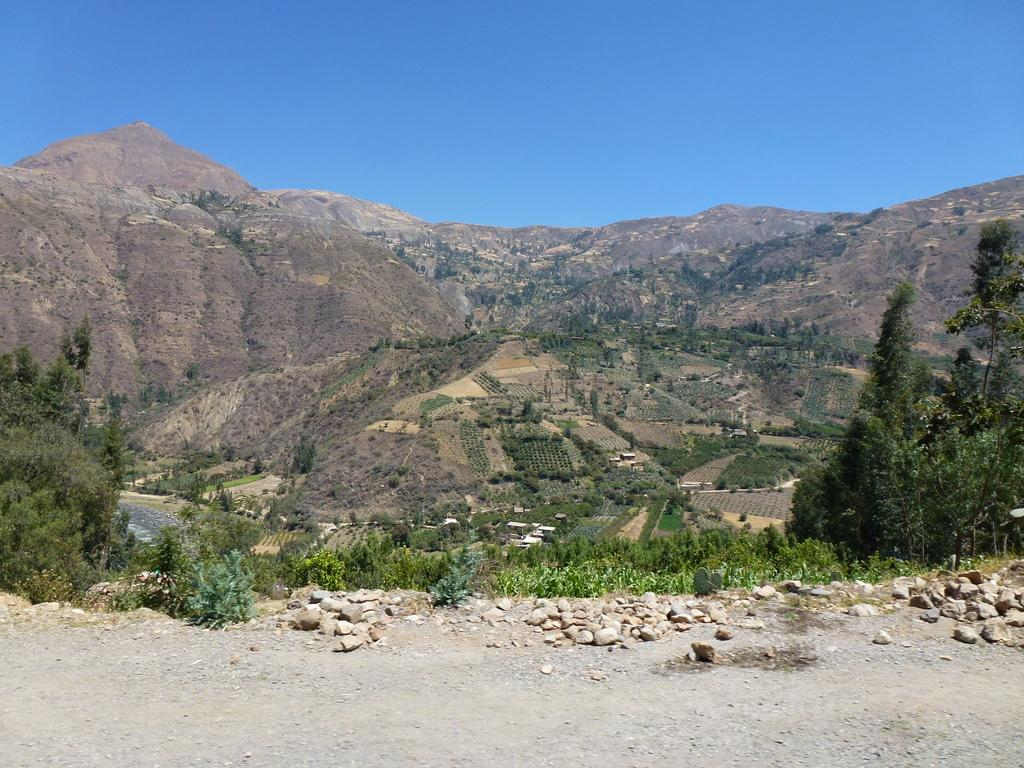What type of vegetation can be seen in the image? There are plants and trees in the image. What other objects can be seen in the image? There are stones in the image. What is visible in the background of the image? There is a hill in the background of the image. What type of silver material can be seen in the image? There is no silver material present in the image. How many girls are visible in the image? There are no girls present in the image. 